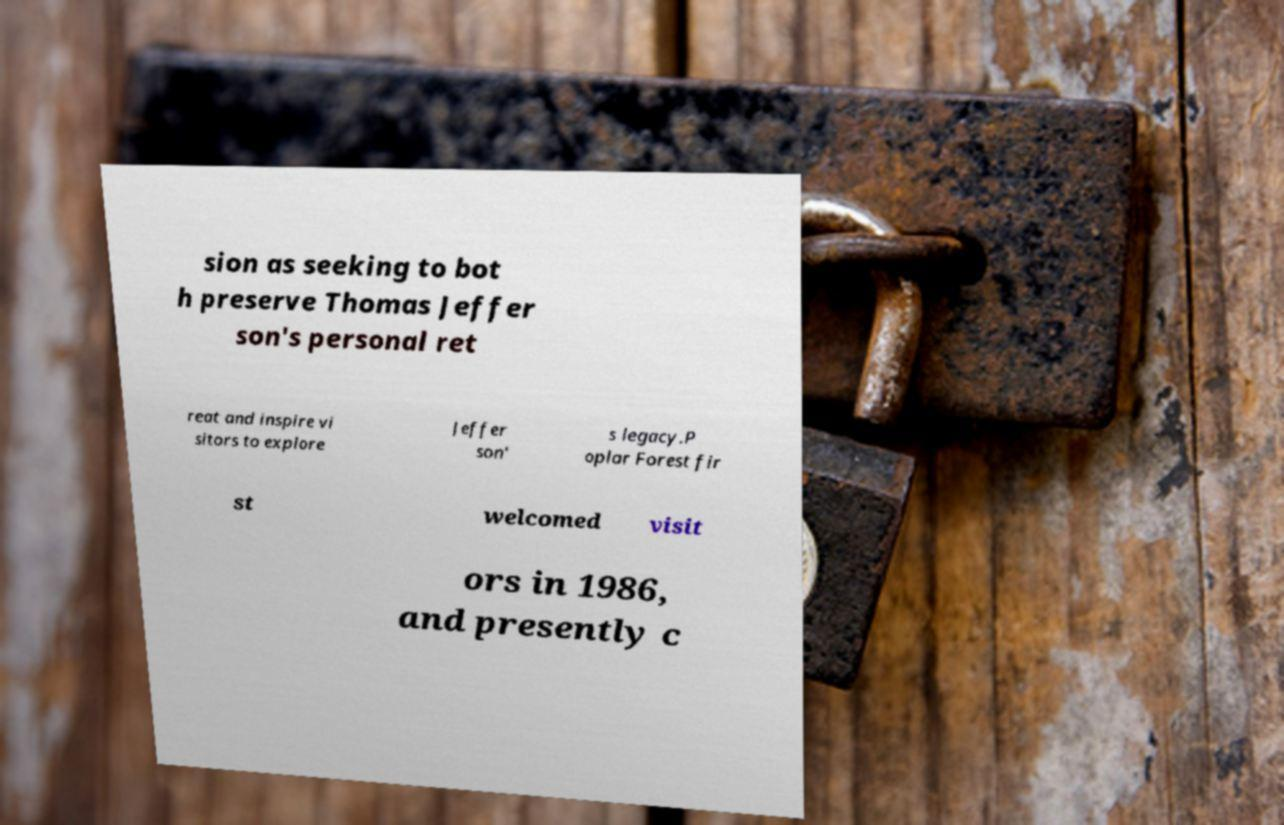There's text embedded in this image that I need extracted. Can you transcribe it verbatim? sion as seeking to bot h preserve Thomas Jeffer son's personal ret reat and inspire vi sitors to explore Jeffer son' s legacy.P oplar Forest fir st welcomed visit ors in 1986, and presently c 